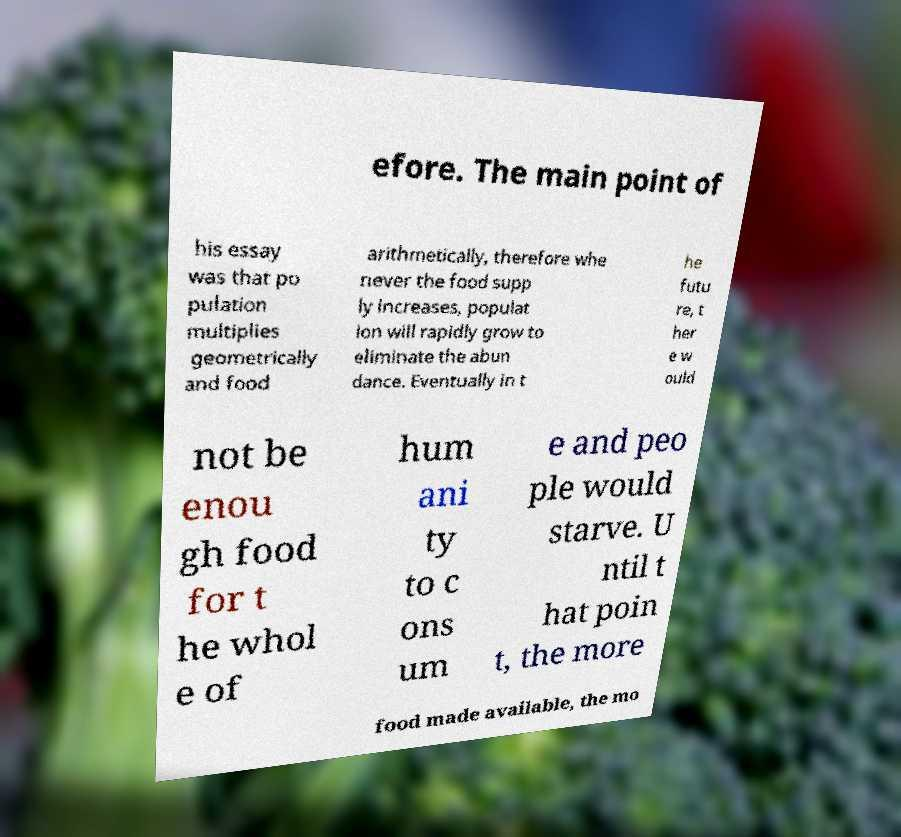For documentation purposes, I need the text within this image transcribed. Could you provide that? efore. The main point of his essay was that po pulation multiplies geometrically and food arithmetically, therefore whe never the food supp ly increases, populat ion will rapidly grow to eliminate the abun dance. Eventually in t he futu re, t her e w ould not be enou gh food for t he whol e of hum ani ty to c ons um e and peo ple would starve. U ntil t hat poin t, the more food made available, the mo 